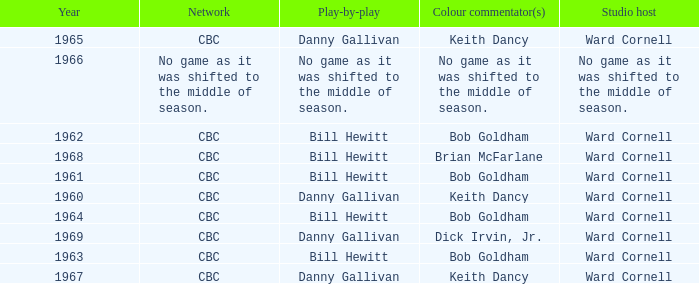Who did the play-by-play with studio host Ward Cornell and color commentator Bob Goldham? Bill Hewitt, Bill Hewitt, Bill Hewitt, Bill Hewitt. Would you mind parsing the complete table? {'header': ['Year', 'Network', 'Play-by-play', 'Colour commentator(s)', 'Studio host'], 'rows': [['1965', 'CBC', 'Danny Gallivan', 'Keith Dancy', 'Ward Cornell'], ['1966', 'No game as it was shifted to the middle of season.', 'No game as it was shifted to the middle of season.', 'No game as it was shifted to the middle of season.', 'No game as it was shifted to the middle of season.'], ['1962', 'CBC', 'Bill Hewitt', 'Bob Goldham', 'Ward Cornell'], ['1968', 'CBC', 'Bill Hewitt', 'Brian McFarlane', 'Ward Cornell'], ['1961', 'CBC', 'Bill Hewitt', 'Bob Goldham', 'Ward Cornell'], ['1960', 'CBC', 'Danny Gallivan', 'Keith Dancy', 'Ward Cornell'], ['1964', 'CBC', 'Bill Hewitt', 'Bob Goldham', 'Ward Cornell'], ['1969', 'CBC', 'Danny Gallivan', 'Dick Irvin, Jr.', 'Ward Cornell'], ['1963', 'CBC', 'Bill Hewitt', 'Bob Goldham', 'Ward Cornell'], ['1967', 'CBC', 'Danny Gallivan', 'Keith Dancy', 'Ward Cornell']]} 